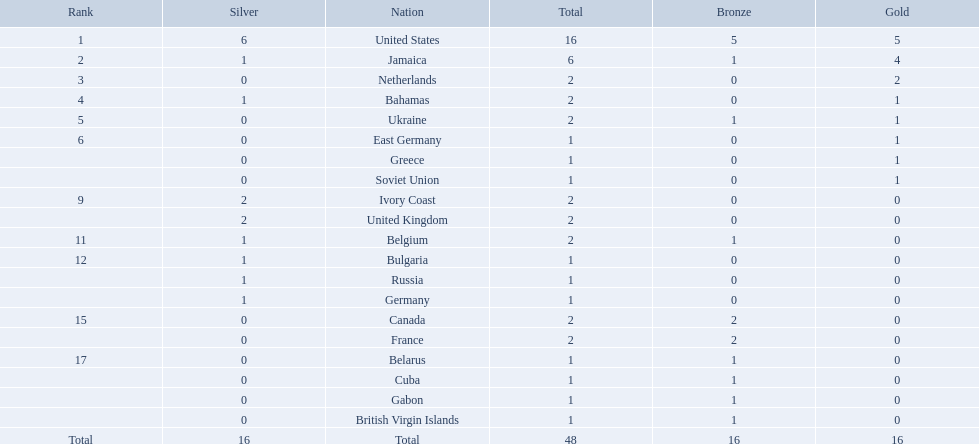What countries competed? United States, Jamaica, Netherlands, Bahamas, Ukraine, East Germany, Greece, Soviet Union, Ivory Coast, United Kingdom, Belgium, Bulgaria, Russia, Germany, Canada, France, Belarus, Cuba, Gabon, British Virgin Islands. Parse the full table in json format. {'header': ['Rank', 'Silver', 'Nation', 'Total', 'Bronze', 'Gold'], 'rows': [['1', '6', 'United States', '16', '5', '5'], ['2', '1', 'Jamaica', '6', '1', '4'], ['3', '0', 'Netherlands', '2', '0', '2'], ['4', '1', 'Bahamas', '2', '0', '1'], ['5', '0', 'Ukraine', '2', '1', '1'], ['6', '0', 'East Germany', '1', '0', '1'], ['', '0', 'Greece', '1', '0', '1'], ['', '0', 'Soviet Union', '1', '0', '1'], ['9', '2', 'Ivory Coast', '2', '0', '0'], ['', '2', 'United Kingdom', '2', '0', '0'], ['11', '1', 'Belgium', '2', '1', '0'], ['12', '1', 'Bulgaria', '1', '0', '0'], ['', '1', 'Russia', '1', '0', '0'], ['', '1', 'Germany', '1', '0', '0'], ['15', '0', 'Canada', '2', '2', '0'], ['', '0', 'France', '2', '2', '0'], ['17', '0', 'Belarus', '1', '1', '0'], ['', '0', 'Cuba', '1', '1', '0'], ['', '0', 'Gabon', '1', '1', '0'], ['', '0', 'British Virgin Islands', '1', '1', '0'], ['Total', '16', 'Total', '48', '16', '16']]} Which countries won gold medals? United States, Jamaica, Netherlands, Bahamas, Ukraine, East Germany, Greece, Soviet Union. Which country had the second most medals? Jamaica. 